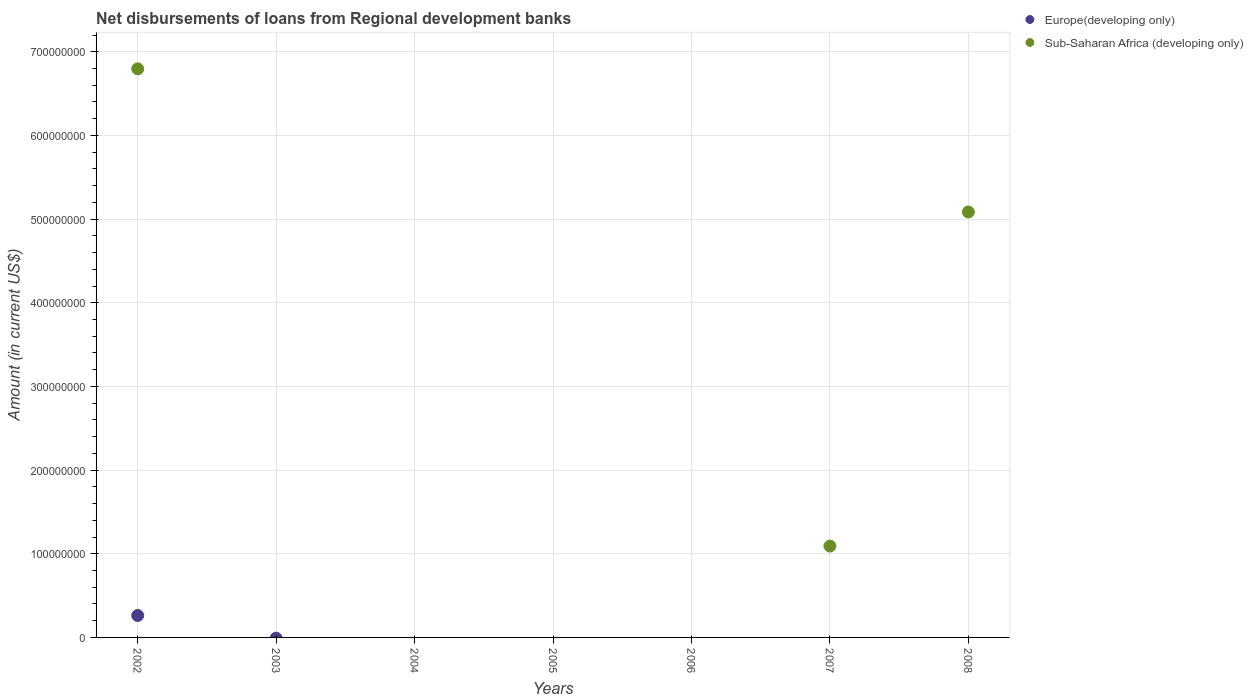Is the number of dotlines equal to the number of legend labels?
Ensure brevity in your answer.  No. Across all years, what is the maximum amount of disbursements of loans from regional development banks in Europe(developing only)?
Your response must be concise. 2.62e+07. In which year was the amount of disbursements of loans from regional development banks in Europe(developing only) maximum?
Make the answer very short. 2002. What is the total amount of disbursements of loans from regional development banks in Sub-Saharan Africa (developing only) in the graph?
Offer a very short reply. 1.30e+09. What is the difference between the amount of disbursements of loans from regional development banks in Europe(developing only) in 2004 and the amount of disbursements of loans from regional development banks in Sub-Saharan Africa (developing only) in 2008?
Your response must be concise. -5.08e+08. What is the average amount of disbursements of loans from regional development banks in Sub-Saharan Africa (developing only) per year?
Provide a succinct answer. 1.85e+08. In the year 2002, what is the difference between the amount of disbursements of loans from regional development banks in Europe(developing only) and amount of disbursements of loans from regional development banks in Sub-Saharan Africa (developing only)?
Provide a short and direct response. -6.53e+08. What is the ratio of the amount of disbursements of loans from regional development banks in Sub-Saharan Africa (developing only) in 2007 to that in 2008?
Your response must be concise. 0.21. What is the difference between the highest and the second highest amount of disbursements of loans from regional development banks in Sub-Saharan Africa (developing only)?
Make the answer very short. 1.71e+08. What is the difference between the highest and the lowest amount of disbursements of loans from regional development banks in Sub-Saharan Africa (developing only)?
Ensure brevity in your answer.  6.80e+08. Is the amount of disbursements of loans from regional development banks in Sub-Saharan Africa (developing only) strictly greater than the amount of disbursements of loans from regional development banks in Europe(developing only) over the years?
Your answer should be very brief. No. Is the amount of disbursements of loans from regional development banks in Europe(developing only) strictly less than the amount of disbursements of loans from regional development banks in Sub-Saharan Africa (developing only) over the years?
Provide a succinct answer. No. How many dotlines are there?
Ensure brevity in your answer.  2. How many years are there in the graph?
Your answer should be compact. 7. Are the values on the major ticks of Y-axis written in scientific E-notation?
Provide a succinct answer. No. Does the graph contain grids?
Provide a short and direct response. Yes. How many legend labels are there?
Provide a succinct answer. 2. How are the legend labels stacked?
Keep it short and to the point. Vertical. What is the title of the graph?
Make the answer very short. Net disbursements of loans from Regional development banks. What is the Amount (in current US$) in Europe(developing only) in 2002?
Offer a very short reply. 2.62e+07. What is the Amount (in current US$) in Sub-Saharan Africa (developing only) in 2002?
Your answer should be very brief. 6.80e+08. What is the Amount (in current US$) in Europe(developing only) in 2003?
Offer a terse response. 0. What is the Amount (in current US$) in Sub-Saharan Africa (developing only) in 2003?
Your answer should be very brief. 0. What is the Amount (in current US$) in Europe(developing only) in 2004?
Provide a succinct answer. 0. What is the Amount (in current US$) in Europe(developing only) in 2005?
Offer a terse response. 0. What is the Amount (in current US$) in Sub-Saharan Africa (developing only) in 2006?
Your response must be concise. 0. What is the Amount (in current US$) in Europe(developing only) in 2007?
Keep it short and to the point. 0. What is the Amount (in current US$) of Sub-Saharan Africa (developing only) in 2007?
Give a very brief answer. 1.09e+08. What is the Amount (in current US$) in Sub-Saharan Africa (developing only) in 2008?
Ensure brevity in your answer.  5.08e+08. Across all years, what is the maximum Amount (in current US$) of Europe(developing only)?
Ensure brevity in your answer.  2.62e+07. Across all years, what is the maximum Amount (in current US$) in Sub-Saharan Africa (developing only)?
Your response must be concise. 6.80e+08. Across all years, what is the minimum Amount (in current US$) of Europe(developing only)?
Your response must be concise. 0. Across all years, what is the minimum Amount (in current US$) of Sub-Saharan Africa (developing only)?
Give a very brief answer. 0. What is the total Amount (in current US$) of Europe(developing only) in the graph?
Offer a very short reply. 2.62e+07. What is the total Amount (in current US$) in Sub-Saharan Africa (developing only) in the graph?
Give a very brief answer. 1.30e+09. What is the difference between the Amount (in current US$) of Sub-Saharan Africa (developing only) in 2002 and that in 2007?
Give a very brief answer. 5.70e+08. What is the difference between the Amount (in current US$) in Sub-Saharan Africa (developing only) in 2002 and that in 2008?
Make the answer very short. 1.71e+08. What is the difference between the Amount (in current US$) of Sub-Saharan Africa (developing only) in 2007 and that in 2008?
Your response must be concise. -3.99e+08. What is the difference between the Amount (in current US$) of Europe(developing only) in 2002 and the Amount (in current US$) of Sub-Saharan Africa (developing only) in 2007?
Offer a very short reply. -8.30e+07. What is the difference between the Amount (in current US$) in Europe(developing only) in 2002 and the Amount (in current US$) in Sub-Saharan Africa (developing only) in 2008?
Give a very brief answer. -4.82e+08. What is the average Amount (in current US$) in Europe(developing only) per year?
Give a very brief answer. 3.74e+06. What is the average Amount (in current US$) in Sub-Saharan Africa (developing only) per year?
Make the answer very short. 1.85e+08. In the year 2002, what is the difference between the Amount (in current US$) in Europe(developing only) and Amount (in current US$) in Sub-Saharan Africa (developing only)?
Make the answer very short. -6.53e+08. What is the ratio of the Amount (in current US$) of Sub-Saharan Africa (developing only) in 2002 to that in 2007?
Your response must be concise. 6.23. What is the ratio of the Amount (in current US$) in Sub-Saharan Africa (developing only) in 2002 to that in 2008?
Offer a terse response. 1.34. What is the ratio of the Amount (in current US$) in Sub-Saharan Africa (developing only) in 2007 to that in 2008?
Provide a succinct answer. 0.21. What is the difference between the highest and the second highest Amount (in current US$) of Sub-Saharan Africa (developing only)?
Offer a very short reply. 1.71e+08. What is the difference between the highest and the lowest Amount (in current US$) of Europe(developing only)?
Your answer should be very brief. 2.62e+07. What is the difference between the highest and the lowest Amount (in current US$) in Sub-Saharan Africa (developing only)?
Make the answer very short. 6.80e+08. 